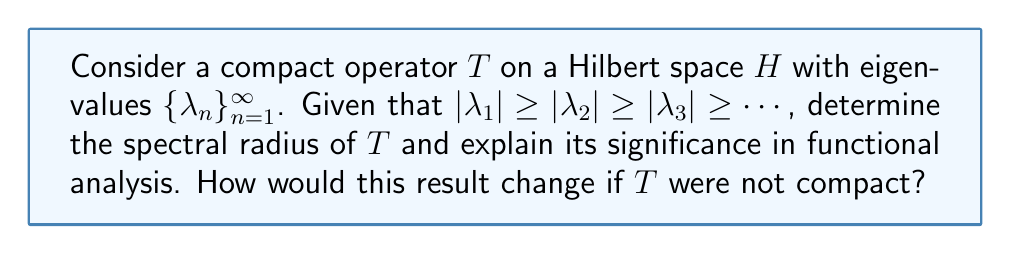Can you answer this question? 1. Recall that for a compact operator $T$ on a Hilbert space $H$, the spectrum $\sigma(T)$ consists of 0 and the eigenvalues of $T$.

2. The spectral radius $r(T)$ is defined as:
   $$r(T) = \sup\{|\lambda| : \lambda \in \sigma(T)\}$$

3. For a compact operator, the eigenvalues form a sequence converging to 0. Therefore:
   $$r(T) = \lim_{n \to \infty} |\lambda_n|^{1/n} = |\lambda_1|$$

4. The significance of the spectral radius for compact operators in functional analysis:
   a) It provides an upper bound for the operator norm: $\|T\| \geq r(T)$
   b) It determines the convergence of the Neumann series: $\sum_{n=0}^{\infty} T^n$ converges if and only if $r(T) < 1$
   c) It characterizes the asymptotic behavior of $\|T^n\|^{1/n}$ as $n \to \infty$

5. If $T$ were not compact:
   a) The spectrum might not consist only of eigenvalues and 0
   b) The spectral radius formula $r(T) = \lim_{n \to \infty} \|T^n\|^{1/n}$ would still hold, but it might not equal $|\lambda_1|$
   c) The spectrum might not be discrete, making the determination of $r(T)$ more complex
Answer: $r(T) = |\lambda_1|$ 